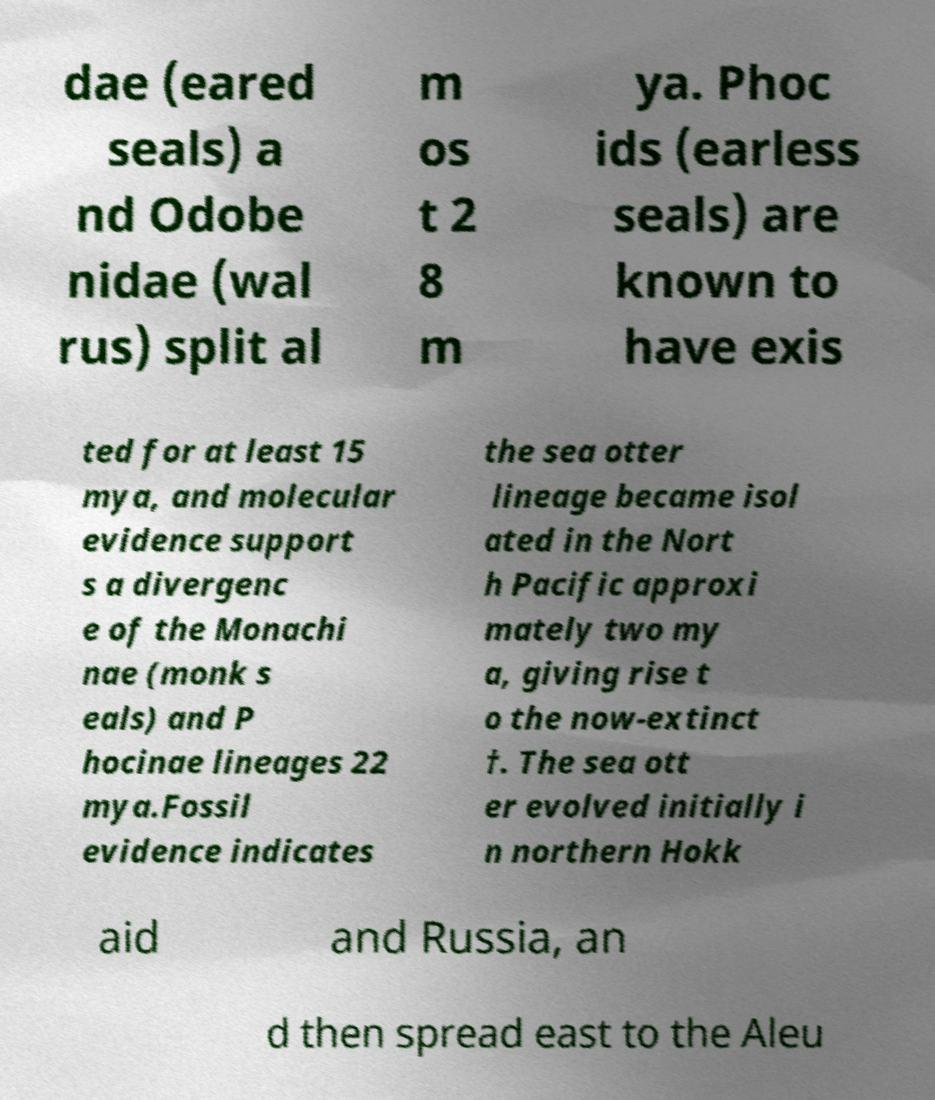Can you accurately transcribe the text from the provided image for me? dae (eared seals) a nd Odobe nidae (wal rus) split al m os t 2 8 m ya. Phoc ids (earless seals) are known to have exis ted for at least 15 mya, and molecular evidence support s a divergenc e of the Monachi nae (monk s eals) and P hocinae lineages 22 mya.Fossil evidence indicates the sea otter lineage became isol ated in the Nort h Pacific approxi mately two my a, giving rise t o the now-extinct †. The sea ott er evolved initially i n northern Hokk aid and Russia, an d then spread east to the Aleu 